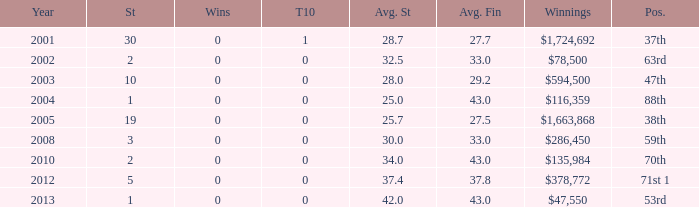How many starts for an average finish greater than 43? None. 